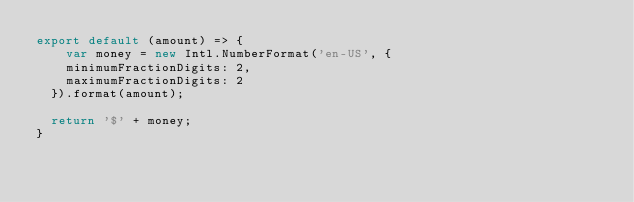Convert code to text. <code><loc_0><loc_0><loc_500><loc_500><_JavaScript_>export default (amount) => {
	var money = new Intl.NumberFormat('en-US', { 
    minimumFractionDigits: 2,
    maximumFractionDigits: 2 
  }).format(amount);
  
  return '$' + money;
}</code> 